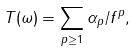<formula> <loc_0><loc_0><loc_500><loc_500>T ( \omega ) = \sum _ { p \geq 1 } \alpha _ { p } / f ^ { p } ,</formula> 